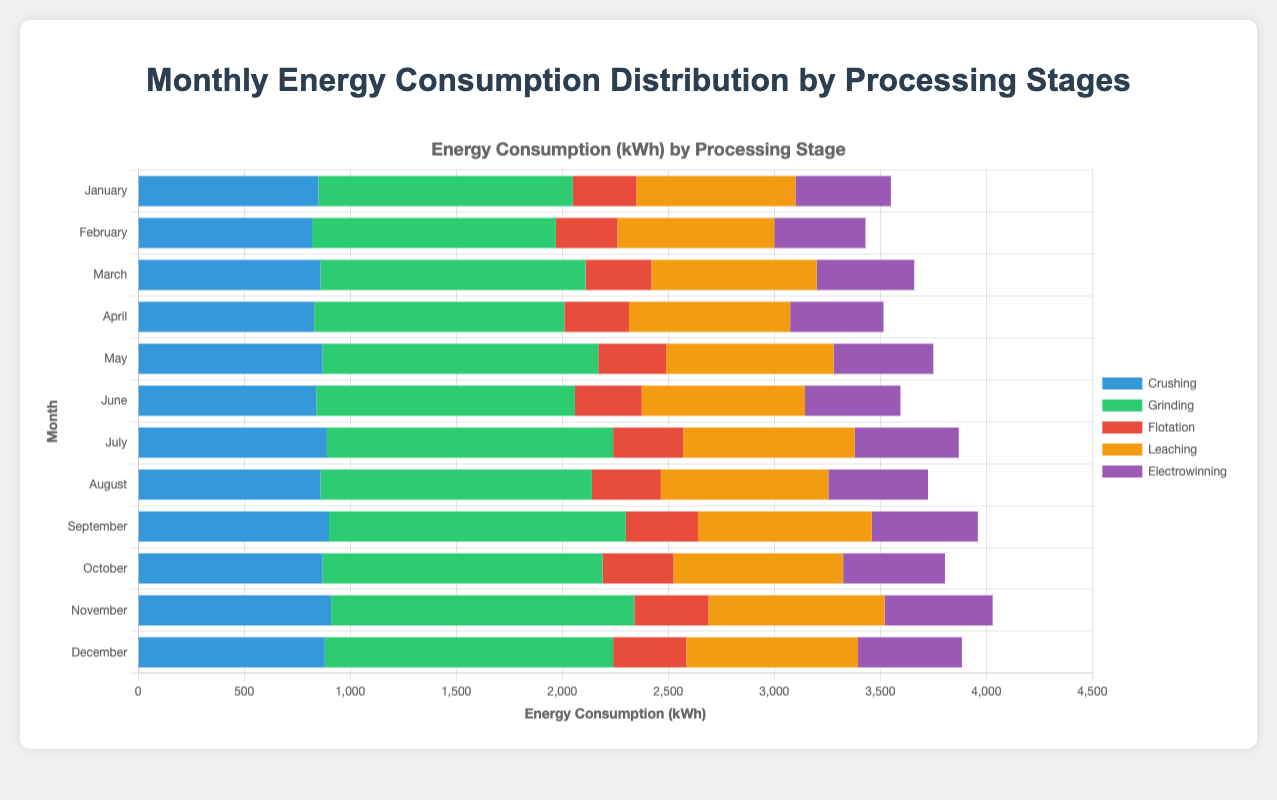what is the total energy consumption in May? To determine the total energy consumption in May, sum the energy values of each processing stage for May: 870 (crushing) + 1300 (grinding) + 320 (flotation) + 790 (leaching) + 470 (electrowinning) = 3750 kWh
Answer: 3750 kWh which month had the highest energy consumption for grinding, and how much was it? By looking at the energy values for grinding across all months, the highest value is 1430 kWh, which occurred in November
Answer: November, 1430 kWh between March and September, which processing stage consistently consumes more energy compared to the other stages in these months? In both March and September, grinding consistently consumes more energy compared to the other stages with values of 1250 kWh in March and 1400 kWh in September
Answer: Grinding what is the average energy consumption for crushing over the entire year? The average is found by summing the monthly crushing values and dividing by 12: (850 + 820 + 860 + 830 + 870 + 840 + 890 + 860 + 900 + 870 + 910 + 880)/12 = 876.67 kWh
Answer: 876.67 kWh which processing stage uses the least energy in October, and what is the value? The least value for October is for flotation with 335 kWh, the lowest among the listed stages for that month
Answer: Flotation, 335 kWh what are the three months with the highest total energy consumption? Summing the total monthly energy values for each month, we find that November (4030 kWh), September (3960 kWh), and July (3870 kWh) are the top three months with the highest total energy consumption
Answer: November, September, July compare the energy consumption for electrowinning between January and December. Which is higher, and by how much? Electrowinning in January is 450 kWh and in December is 490 kWh; December’s value is higher by 40 kWh (490 - 450)
Answer: December, by 40 kWh what is the total energy consumption for flotation across the entire year? Summing the energy values for flotation over the 12 months: 300 + 290 + 310 + 305 + 320 + 315 + 330 + 325 + 340 + 335 + 350 + 345 = 3865 kWh
Answer: 3865 kWh which month has the highest leaching energy consumption, and what is that value? The highest leaching energy value is in November, with a consumption of 830 kWh
Answer: November, 830 kWh 